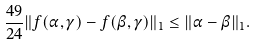Convert formula to latex. <formula><loc_0><loc_0><loc_500><loc_500>\frac { 4 9 } { 2 4 } \| f ( \alpha , \gamma ) - f ( \beta , \gamma ) \| _ { 1 } \leq \| \alpha - \beta \| _ { 1 } .</formula> 